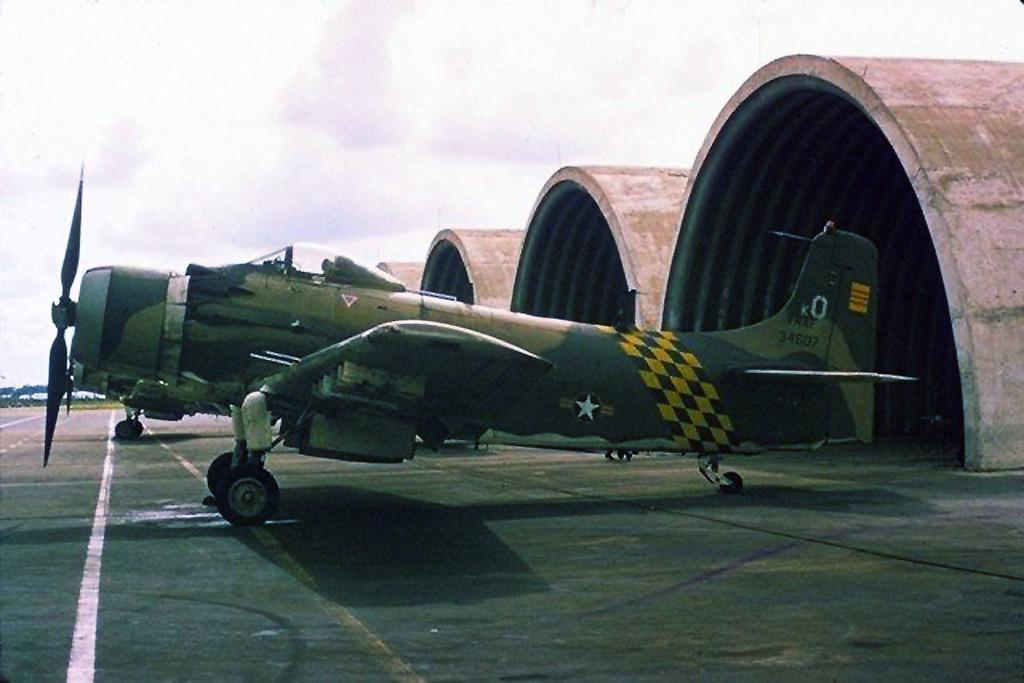<image>
Summarize the visual content of the image. A military plane has number 34607 on the tail. 